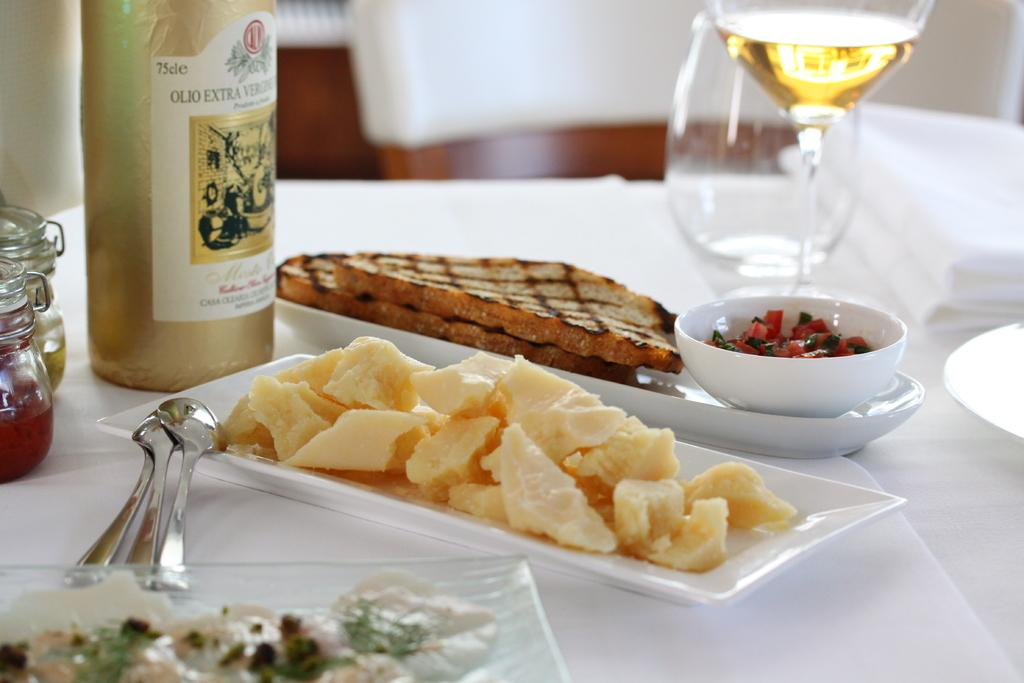What type of dishware is used for the food items in the image? There are white plates used for the food items in the image. What specific type of food can be seen in the image? There are breads in the image. What utensils are present in the image? There are spoons in the image. What type of container is present in the image? There is a bottle in the image. Where are the glass jars located in the image? The glass jars are on the left side of the image. What type of glassware is present in the image? There are wine glasses in the image. What type of fabric is present in the image? There is a white cloth in the image. Where is the white cloth located in the image? The white cloth is at the back of the image. How does the industry contribute to the increase of food items in the image? The image does not depict any industrial influence or an increase in food items; it simply shows food items on plates. How many feet can be seen in the image? There are no feet visible in the image. 